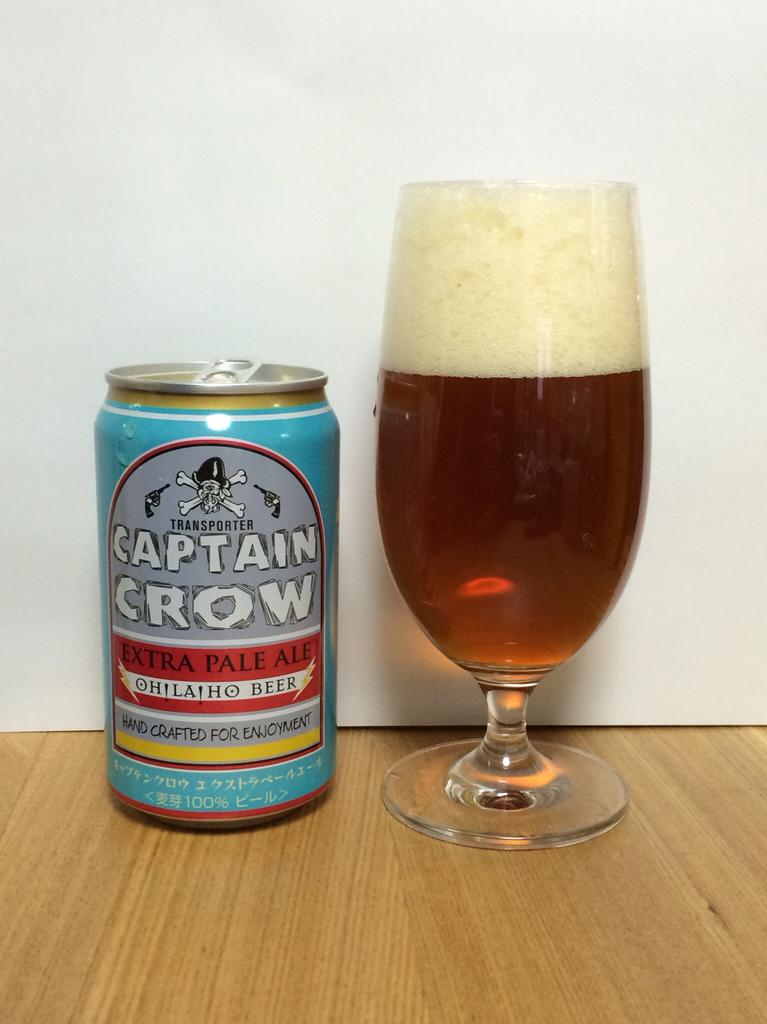<image>
Provide a brief description of the given image. A can of Captain Crow sits next to a glass filled with liquid. 